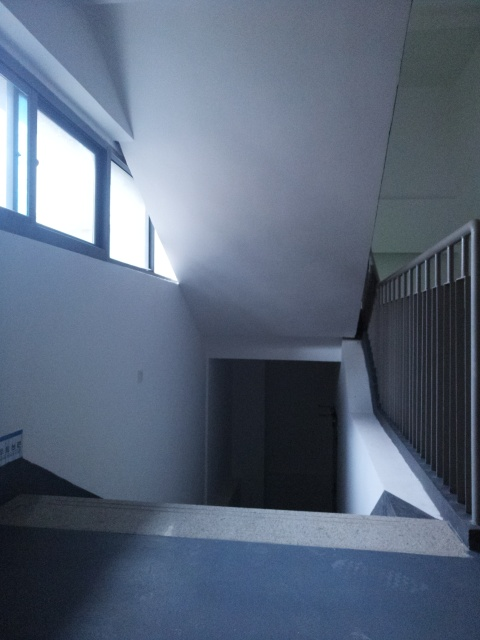Are there any quality issues with this image? Yes, there are several quality issues with the image. It is underexposed, which makes details in the darker areas hard to discern. There is also a slight blur, possibly due to camera shake or focus issues, reducing the sharpness and clarity of the image. 